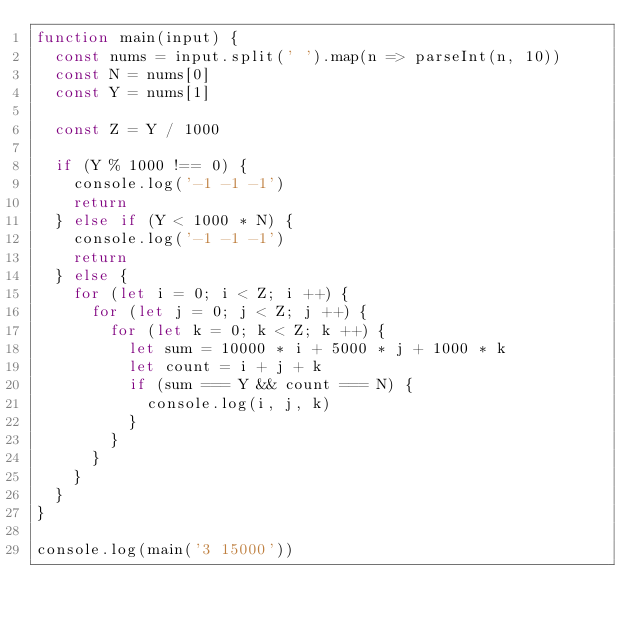<code> <loc_0><loc_0><loc_500><loc_500><_JavaScript_>function main(input) {
  const nums = input.split(' ').map(n => parseInt(n, 10))
  const N = nums[0]
  const Y = nums[1]

  const Z = Y / 1000

  if (Y % 1000 !== 0) {
    console.log('-1 -1 -1')
    return
  } else if (Y < 1000 * N) {
    console.log('-1 -1 -1')
    return 
  } else {
    for (let i = 0; i < Z; i ++) {
      for (let j = 0; j < Z; j ++) {
        for (let k = 0; k < Z; k ++) {
          let sum = 10000 * i + 5000 * j + 1000 * k
          let count = i + j + k
          if (sum === Y && count === N) {
            console.log(i, j, k)
          }
        }
      }
    }
  }
}

console.log(main('3 15000'))</code> 